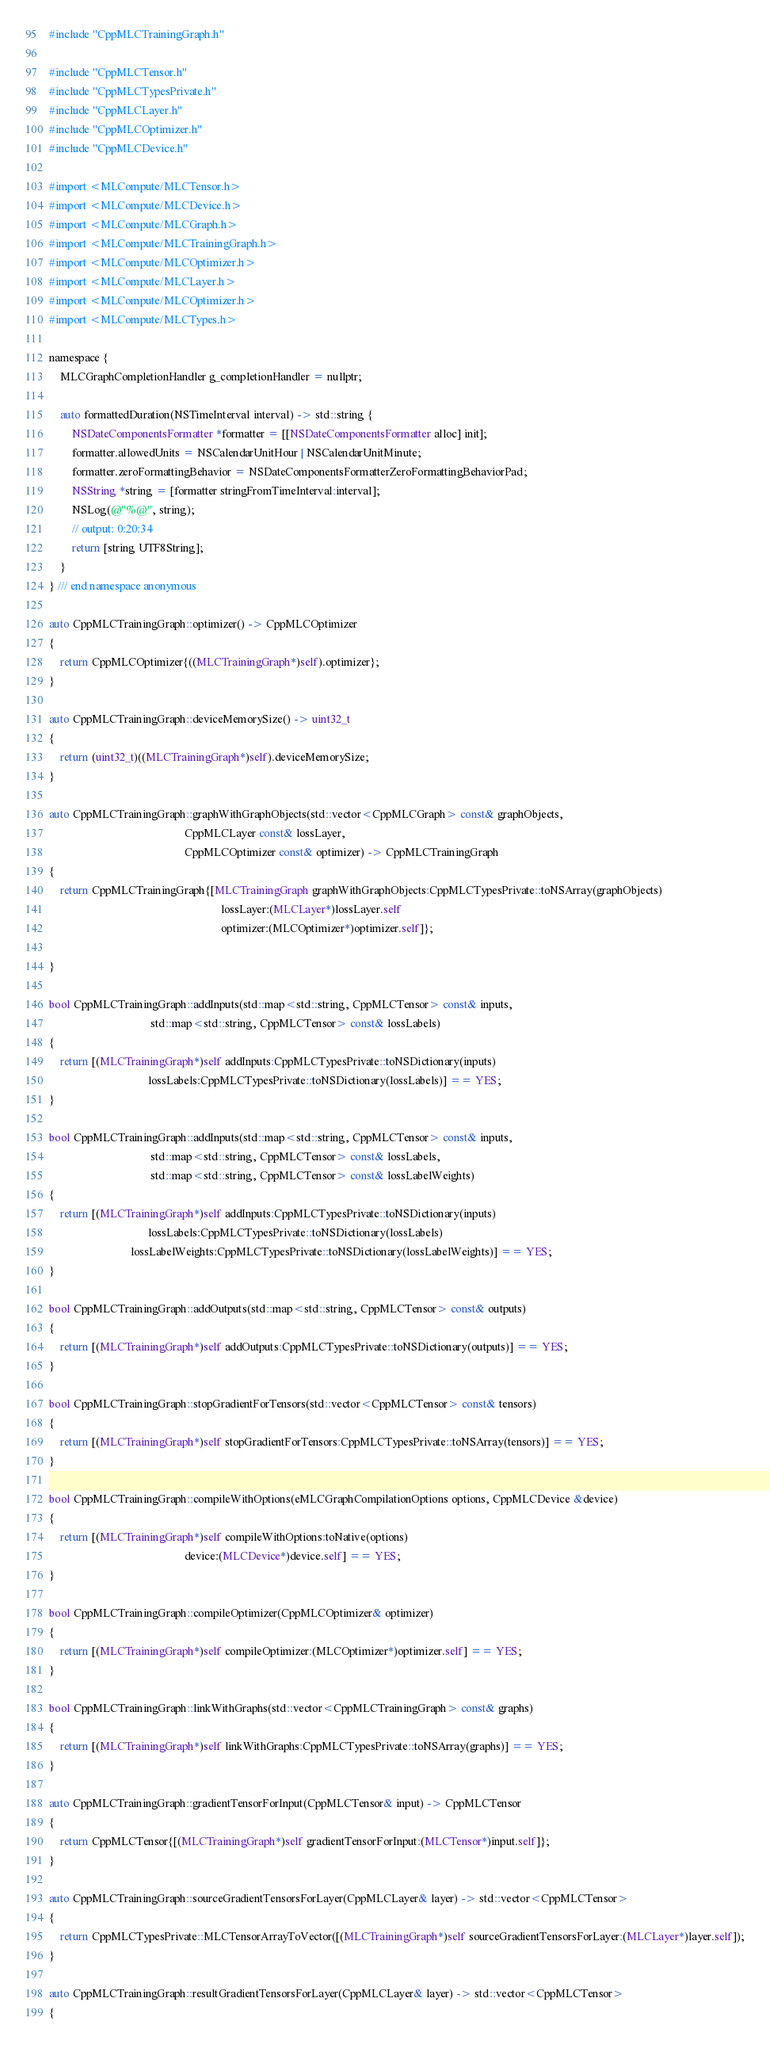<code> <loc_0><loc_0><loc_500><loc_500><_ObjectiveC_>#include "CppMLCTrainingGraph.h"

#include "CppMLCTensor.h"
#include "CppMLCTypesPrivate.h"
#include "CppMLCLayer.h"
#include "CppMLCOptimizer.h"
#include "CppMLCDevice.h"

#import <MLCompute/MLCTensor.h>
#import <MLCompute/MLCDevice.h>
#import <MLCompute/MLCGraph.h>
#import <MLCompute/MLCTrainingGraph.h>
#import <MLCompute/MLCOptimizer.h>
#import <MLCompute/MLCLayer.h>
#import <MLCompute/MLCOptimizer.h>
#import <MLCompute/MLCTypes.h>

namespace {
    MLCGraphCompletionHandler g_completionHandler = nullptr;

    auto formattedDuration(NSTimeInterval interval) -> std::string {
        NSDateComponentsFormatter *formatter = [[NSDateComponentsFormatter alloc] init];
        formatter.allowedUnits = NSCalendarUnitHour | NSCalendarUnitMinute;
        formatter.zeroFormattingBehavior = NSDateComponentsFormatterZeroFormattingBehaviorPad;
        NSString *string = [formatter stringFromTimeInterval:interval];
        NSLog(@"%@", string);
        // output: 0:20:34
        return [string UTF8String];
    }
} /// end namespace anonymous

auto CppMLCTrainingGraph::optimizer() -> CppMLCOptimizer
{
    return CppMLCOptimizer{((MLCTrainingGraph*)self).optimizer};
}

auto CppMLCTrainingGraph::deviceMemorySize() -> uint32_t
{
    return (uint32_t)((MLCTrainingGraph*)self).deviceMemorySize;
}

auto CppMLCTrainingGraph::graphWithGraphObjects(std::vector<CppMLCGraph> const& graphObjects,
                                                CppMLCLayer const& lossLayer,
                                                CppMLCOptimizer const& optimizer) -> CppMLCTrainingGraph
{
    return CppMLCTrainingGraph{[MLCTrainingGraph graphWithGraphObjects:CppMLCTypesPrivate::toNSArray(graphObjects)
                                                             lossLayer:(MLCLayer*)lossLayer.self
                                                             optimizer:(MLCOptimizer*)optimizer.self]};

}

bool CppMLCTrainingGraph::addInputs(std::map<std::string, CppMLCTensor> const& inputs,
                                    std::map<std::string, CppMLCTensor> const& lossLabels)
{
    return [(MLCTrainingGraph*)self addInputs:CppMLCTypesPrivate::toNSDictionary(inputs)
                                   lossLabels:CppMLCTypesPrivate::toNSDictionary(lossLabels)] == YES;
}

bool CppMLCTrainingGraph::addInputs(std::map<std::string, CppMLCTensor> const& inputs,
                                    std::map<std::string, CppMLCTensor> const& lossLabels,
                                    std::map<std::string, CppMLCTensor> const& lossLabelWeights)
{
    return [(MLCTrainingGraph*)self addInputs:CppMLCTypesPrivate::toNSDictionary(inputs)
                                   lossLabels:CppMLCTypesPrivate::toNSDictionary(lossLabels)
                             lossLabelWeights:CppMLCTypesPrivate::toNSDictionary(lossLabelWeights)] == YES;
}

bool CppMLCTrainingGraph::addOutputs(std::map<std::string, CppMLCTensor> const& outputs)
{
    return [(MLCTrainingGraph*)self addOutputs:CppMLCTypesPrivate::toNSDictionary(outputs)] == YES;
}

bool CppMLCTrainingGraph::stopGradientForTensors(std::vector<CppMLCTensor> const& tensors)
{
    return [(MLCTrainingGraph*)self stopGradientForTensors:CppMLCTypesPrivate::toNSArray(tensors)] == YES;
}

bool CppMLCTrainingGraph::compileWithOptions(eMLCGraphCompilationOptions options, CppMLCDevice &device)
{
    return [(MLCTrainingGraph*)self compileWithOptions:toNative(options)
                                                device:(MLCDevice*)device.self] == YES;
}

bool CppMLCTrainingGraph::compileOptimizer(CppMLCOptimizer& optimizer)
{
    return [(MLCTrainingGraph*)self compileOptimizer:(MLCOptimizer*)optimizer.self] == YES;
}

bool CppMLCTrainingGraph::linkWithGraphs(std::vector<CppMLCTrainingGraph> const& graphs)
{
    return [(MLCTrainingGraph*)self linkWithGraphs:CppMLCTypesPrivate::toNSArray(graphs)] == YES;
}

auto CppMLCTrainingGraph::gradientTensorForInput(CppMLCTensor& input) -> CppMLCTensor
{
    return CppMLCTensor{[(MLCTrainingGraph*)self gradientTensorForInput:(MLCTensor*)input.self]};
}

auto CppMLCTrainingGraph::sourceGradientTensorsForLayer(CppMLCLayer& layer) -> std::vector<CppMLCTensor>
{
    return CppMLCTypesPrivate::MLCTensorArrayToVector([(MLCTrainingGraph*)self sourceGradientTensorsForLayer:(MLCLayer*)layer.self]);
}

auto CppMLCTrainingGraph::resultGradientTensorsForLayer(CppMLCLayer& layer) -> std::vector<CppMLCTensor>
{</code> 